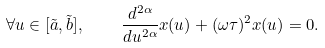<formula> <loc_0><loc_0><loc_500><loc_500>\forall u \in [ \tilde { a } , \tilde { b } ] , \quad \frac { d ^ { 2 \alpha } } { d u ^ { 2 \alpha } } x ( u ) + ( \omega \tau ) ^ { 2 } x ( u ) = 0 .</formula> 